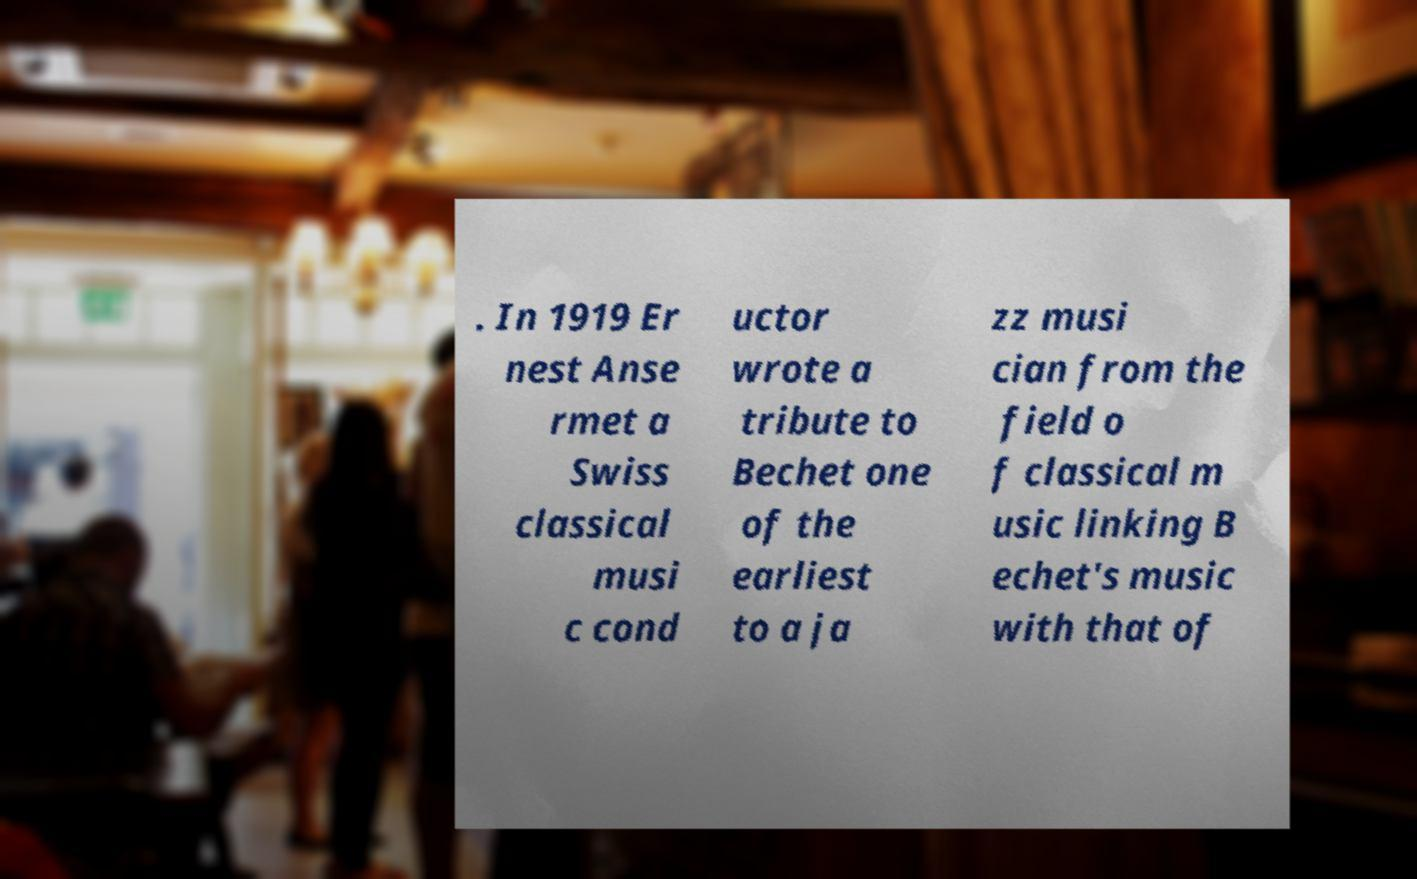Could you assist in decoding the text presented in this image and type it out clearly? . In 1919 Er nest Anse rmet a Swiss classical musi c cond uctor wrote a tribute to Bechet one of the earliest to a ja zz musi cian from the field o f classical m usic linking B echet's music with that of 